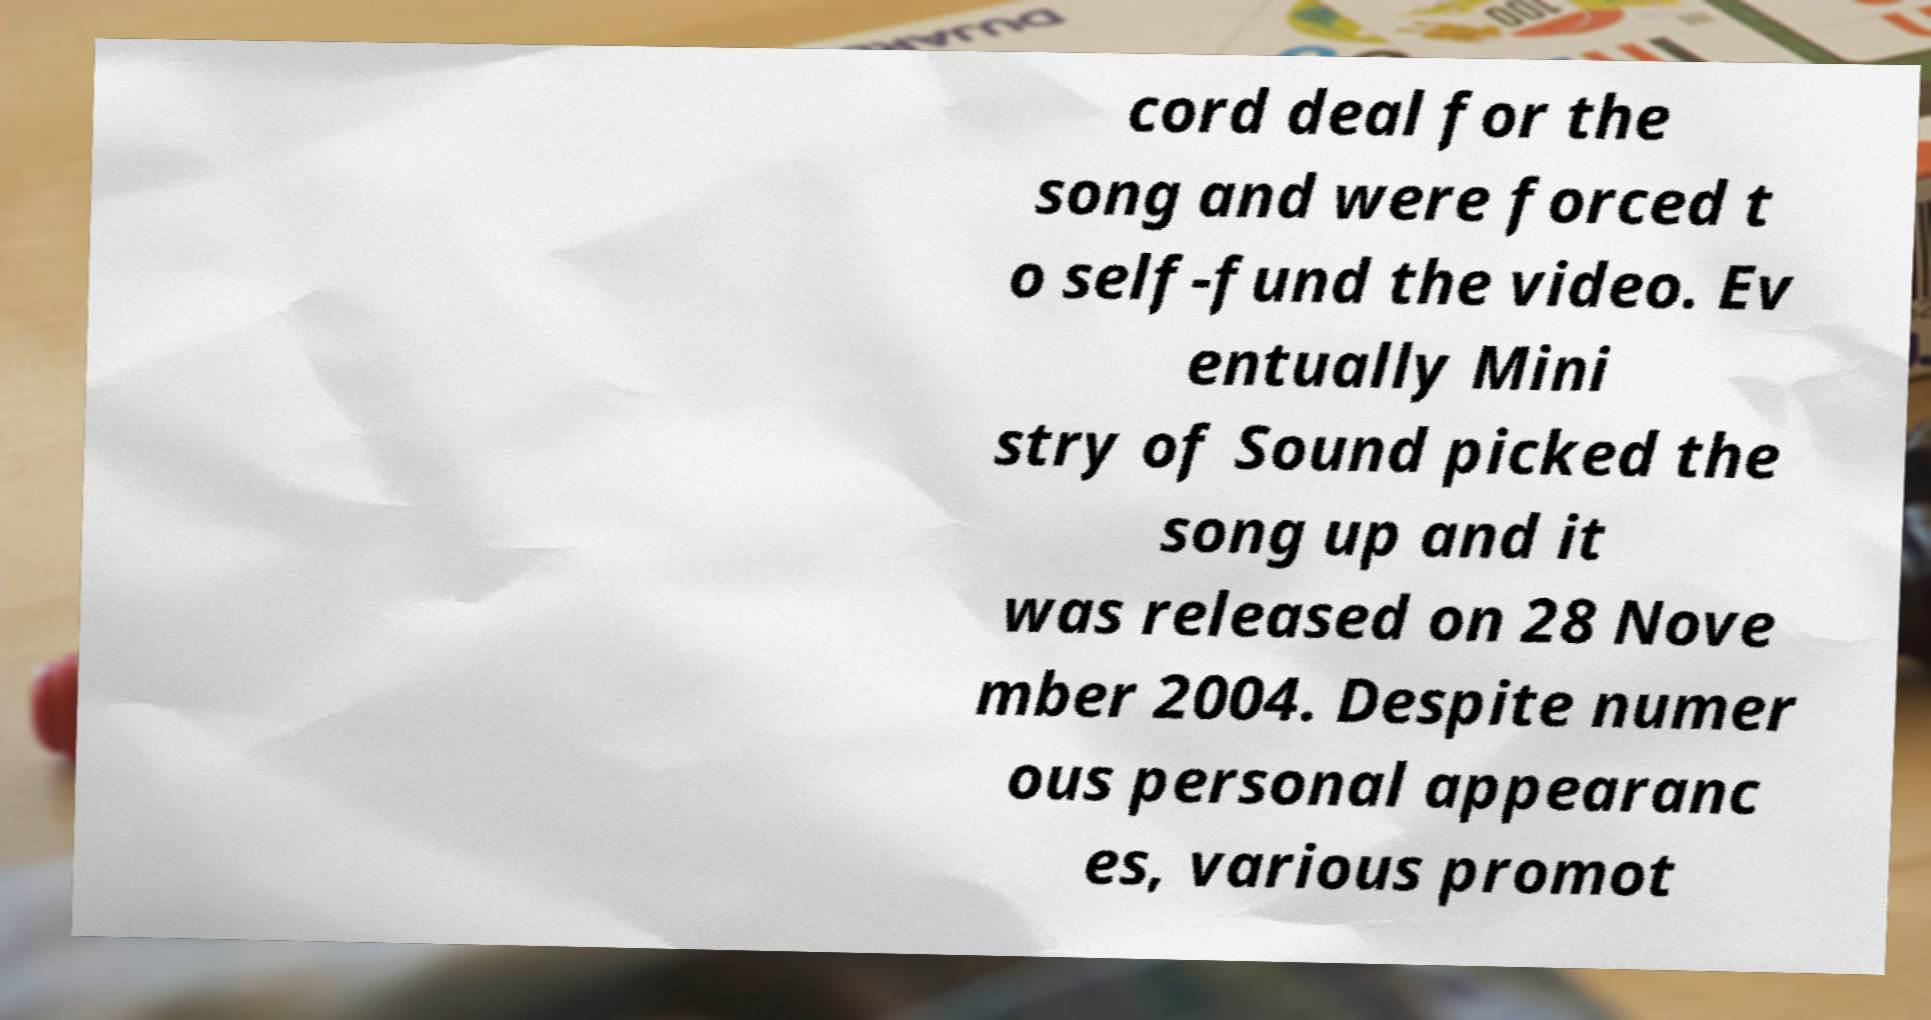Please identify and transcribe the text found in this image. cord deal for the song and were forced t o self-fund the video. Ev entually Mini stry of Sound picked the song up and it was released on 28 Nove mber 2004. Despite numer ous personal appearanc es, various promot 